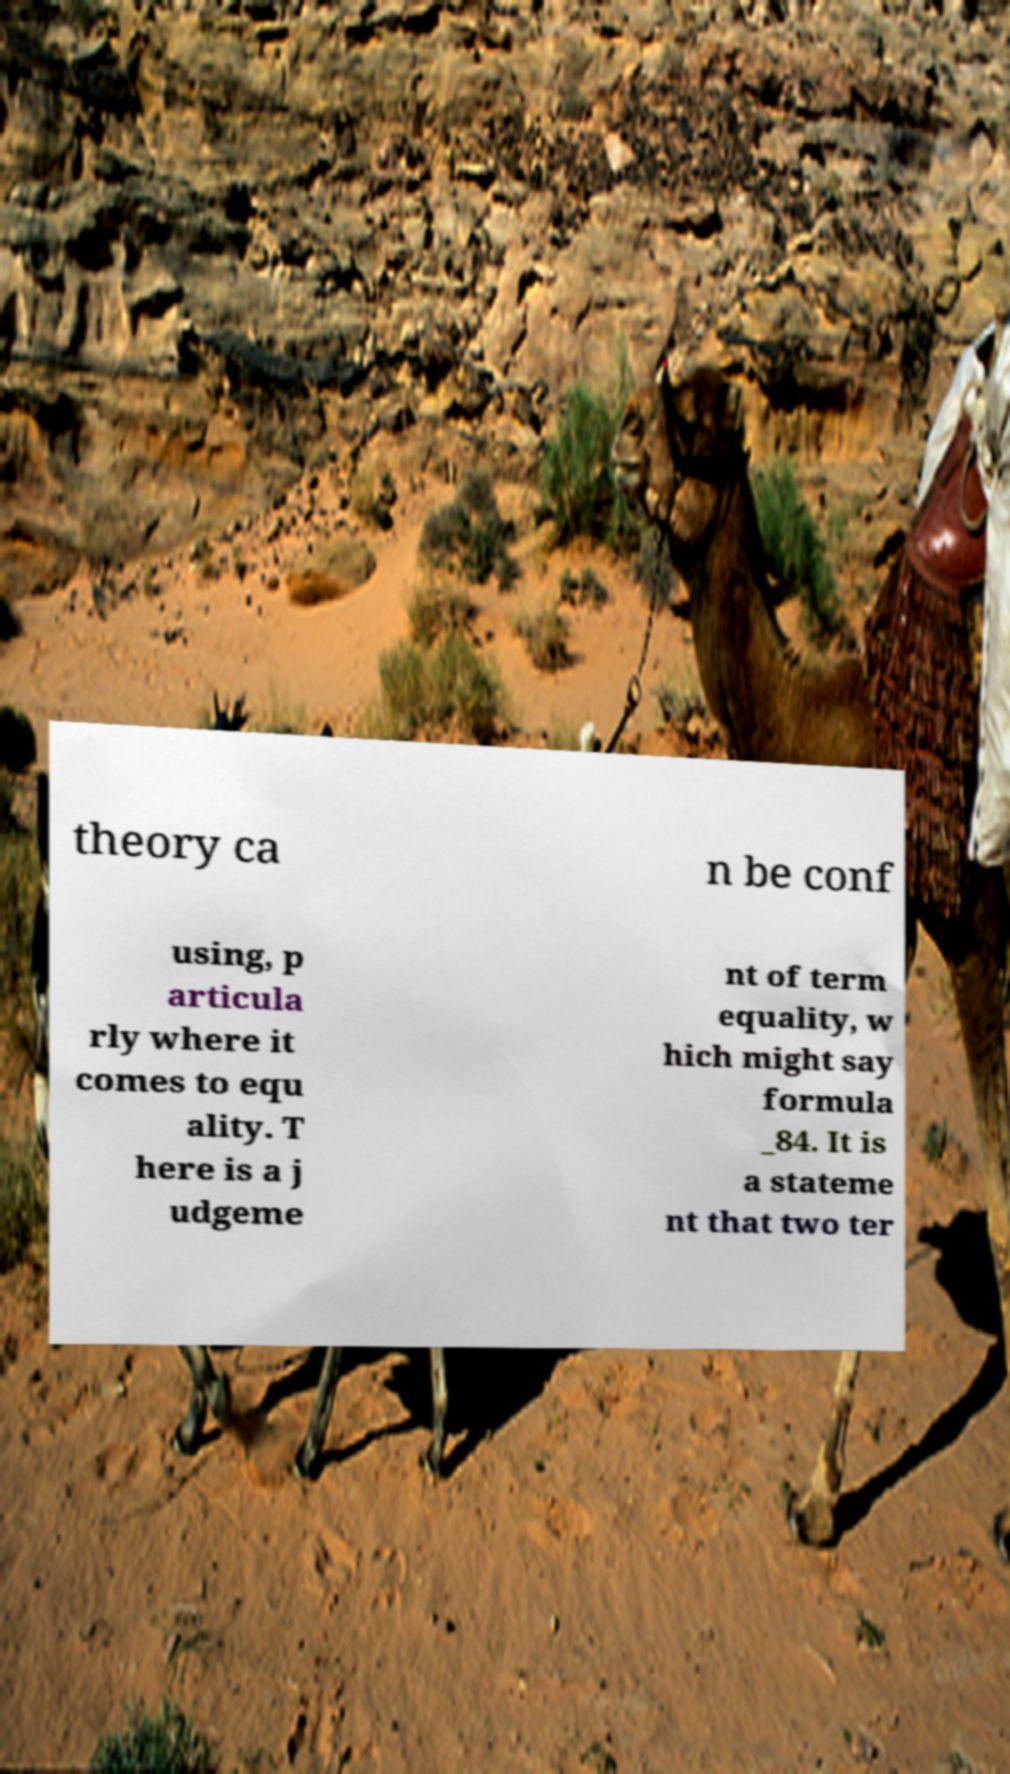For documentation purposes, I need the text within this image transcribed. Could you provide that? theory ca n be conf using, p articula rly where it comes to equ ality. T here is a j udgeme nt of term equality, w hich might say formula _84. It is a stateme nt that two ter 